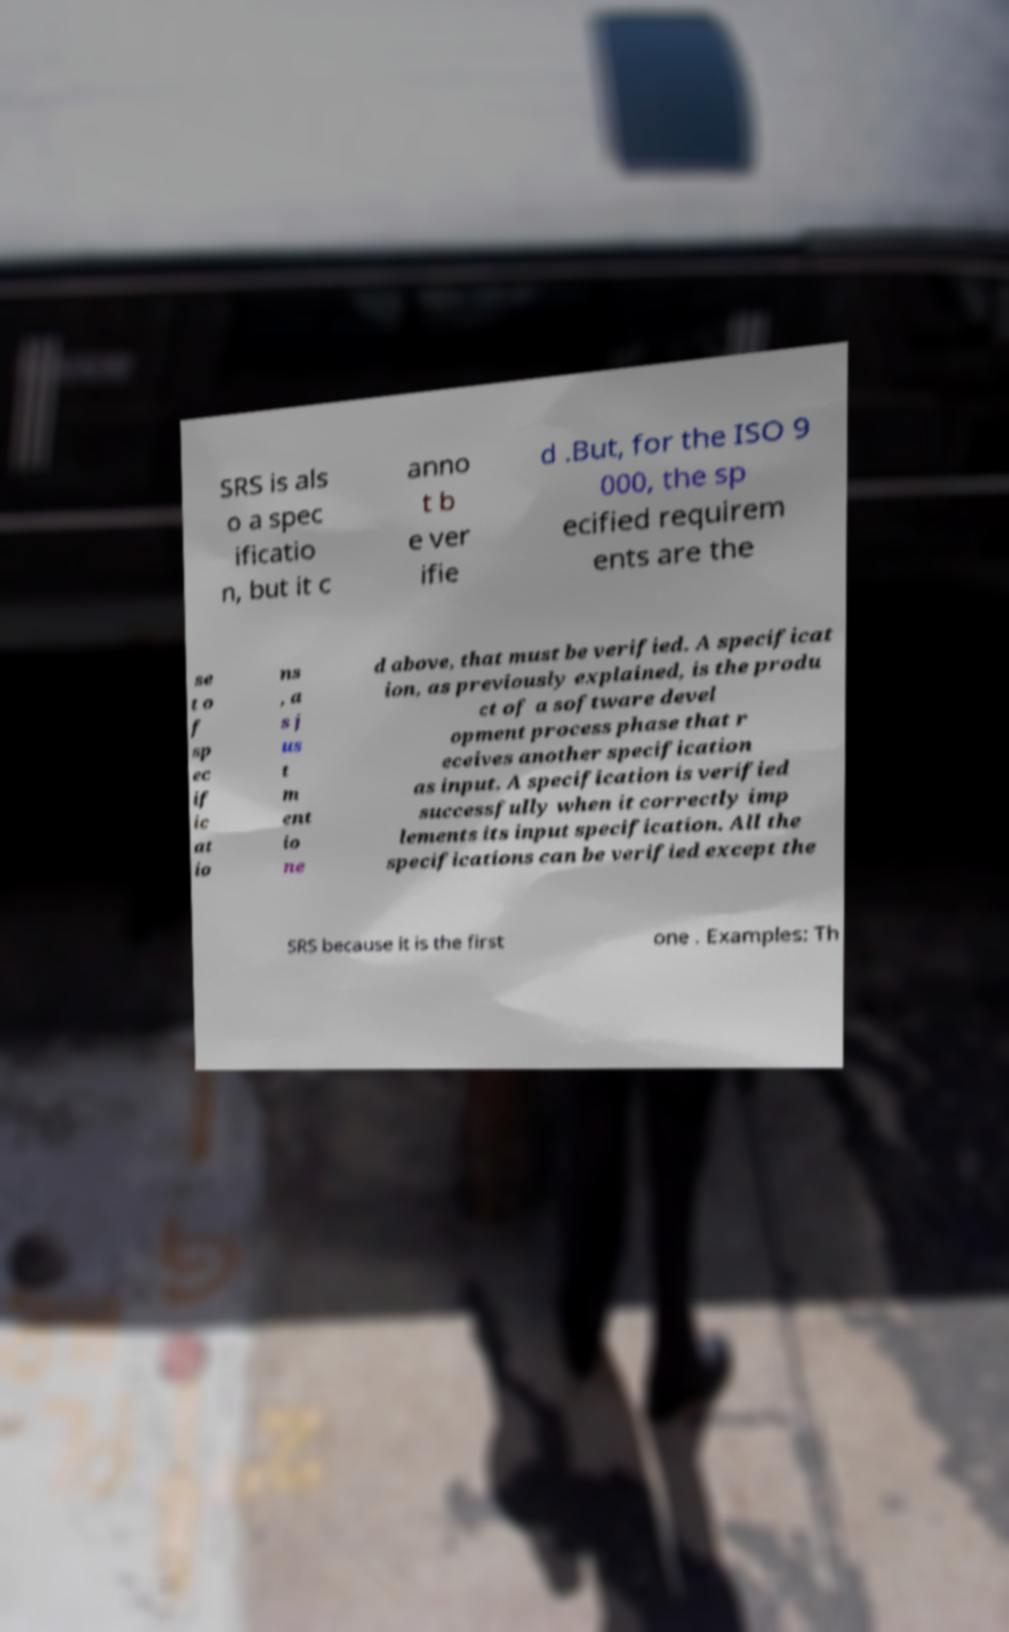Could you extract and type out the text from this image? SRS is als o a spec ificatio n, but it c anno t b e ver ifie d .But, for the ISO 9 000, the sp ecified requirem ents are the se t o f sp ec if ic at io ns , a s j us t m ent io ne d above, that must be verified. A specificat ion, as previously explained, is the produ ct of a software devel opment process phase that r eceives another specification as input. A specification is verified successfully when it correctly imp lements its input specification. All the specifications can be verified except the SRS because it is the first one . Examples: Th 